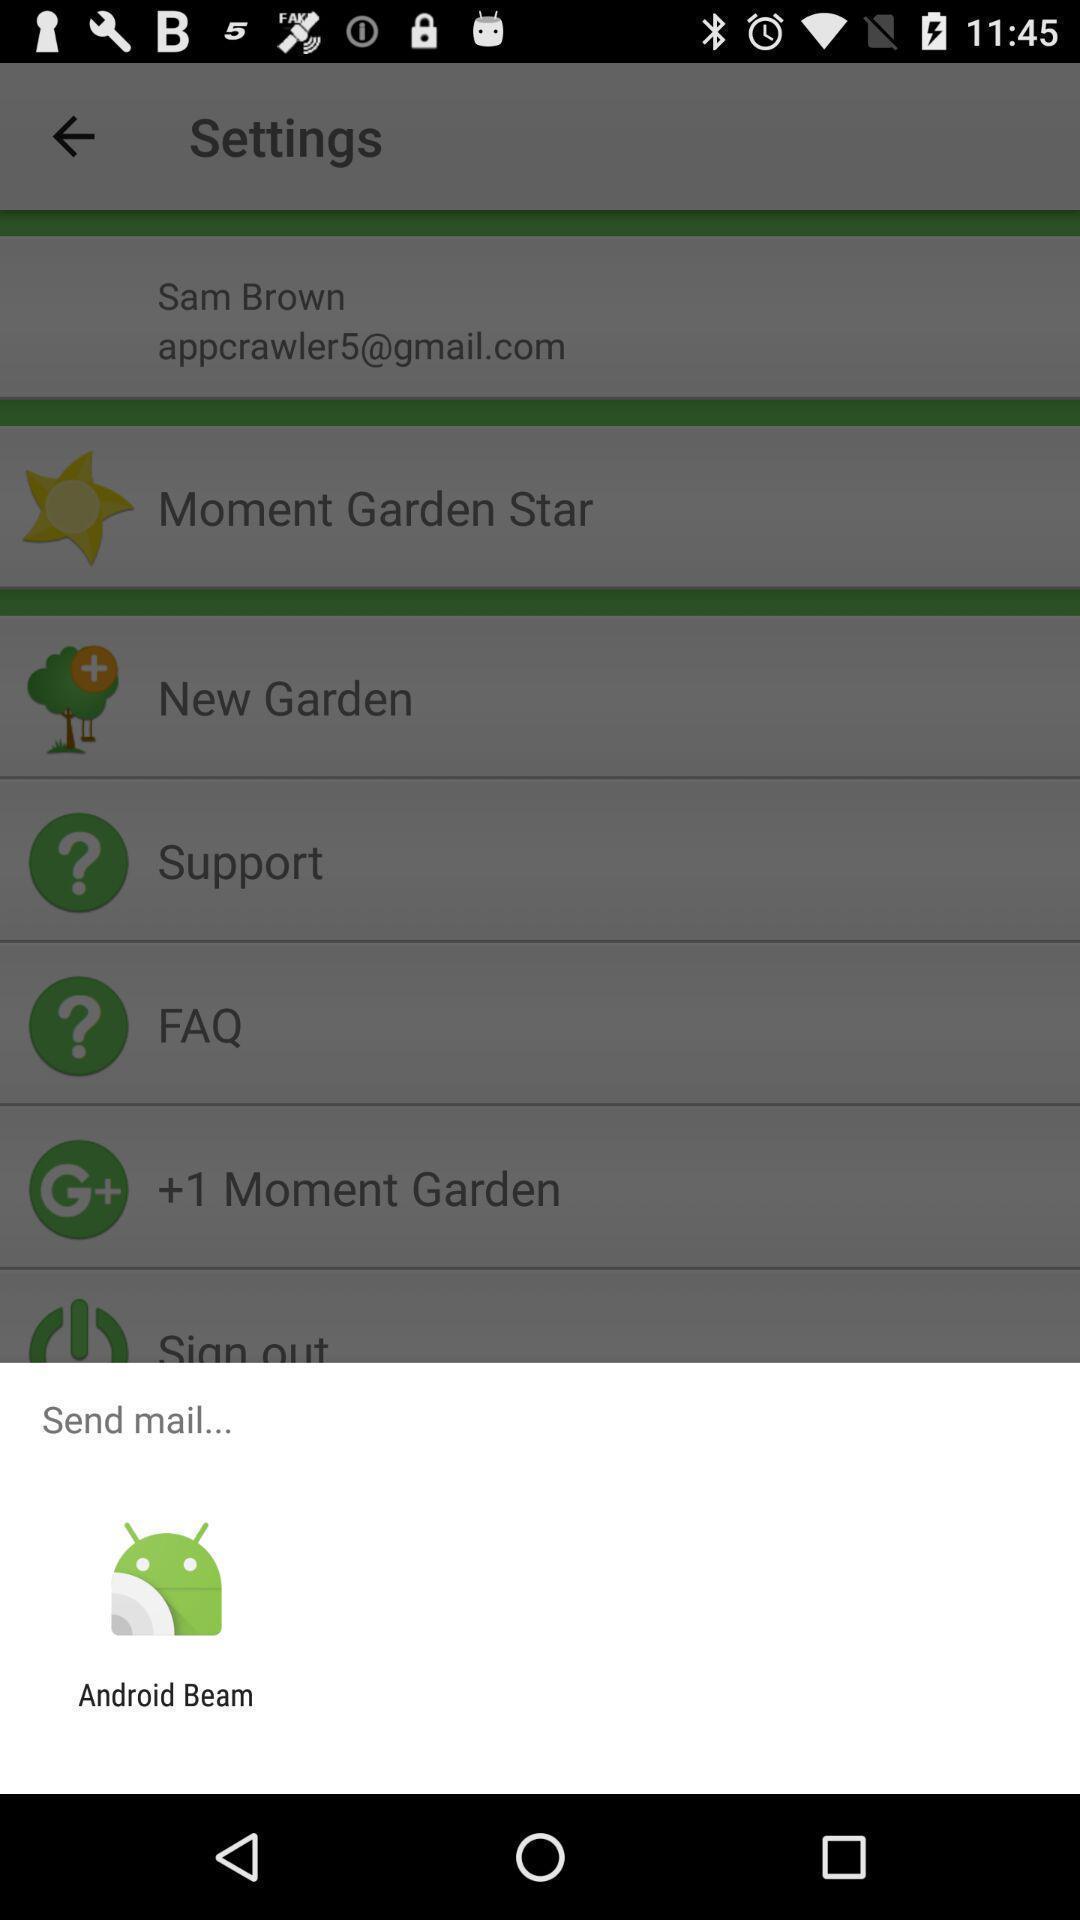What can you discern from this picture? Settings page. 